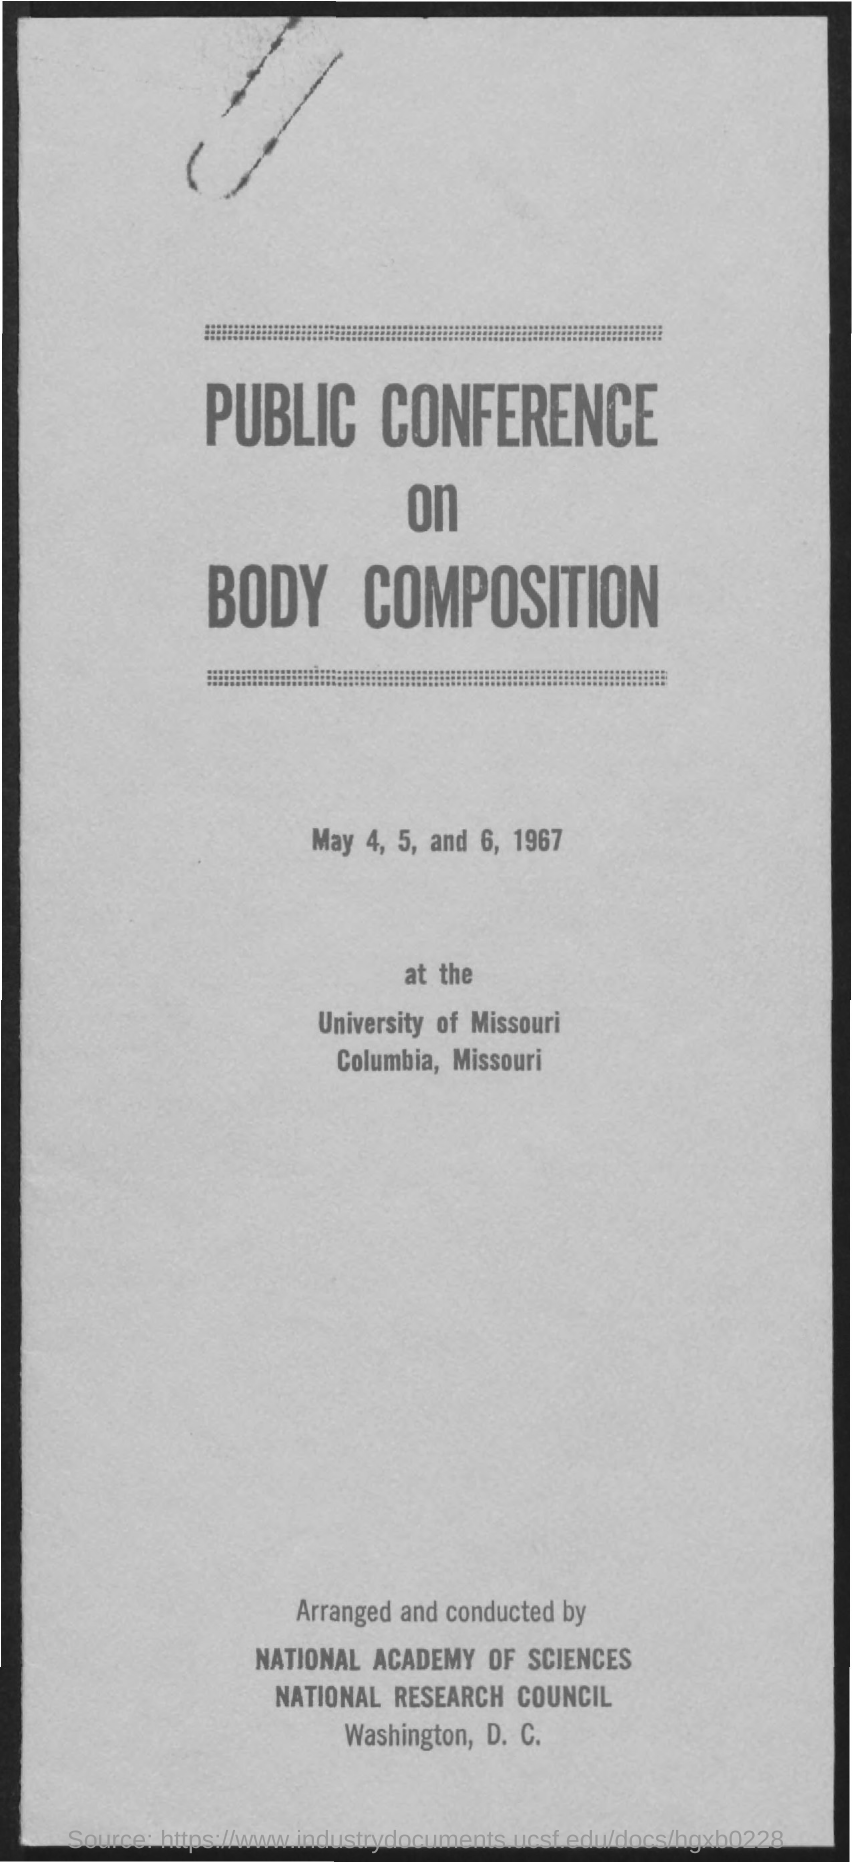List a handful of essential elements in this visual. The public conference is scheduled to take place on May 4, 5, and 6, 1967. The title of the document is "A Public Conference on Body Composition. The public conference on body composition is taking place at the University of Missouri. 